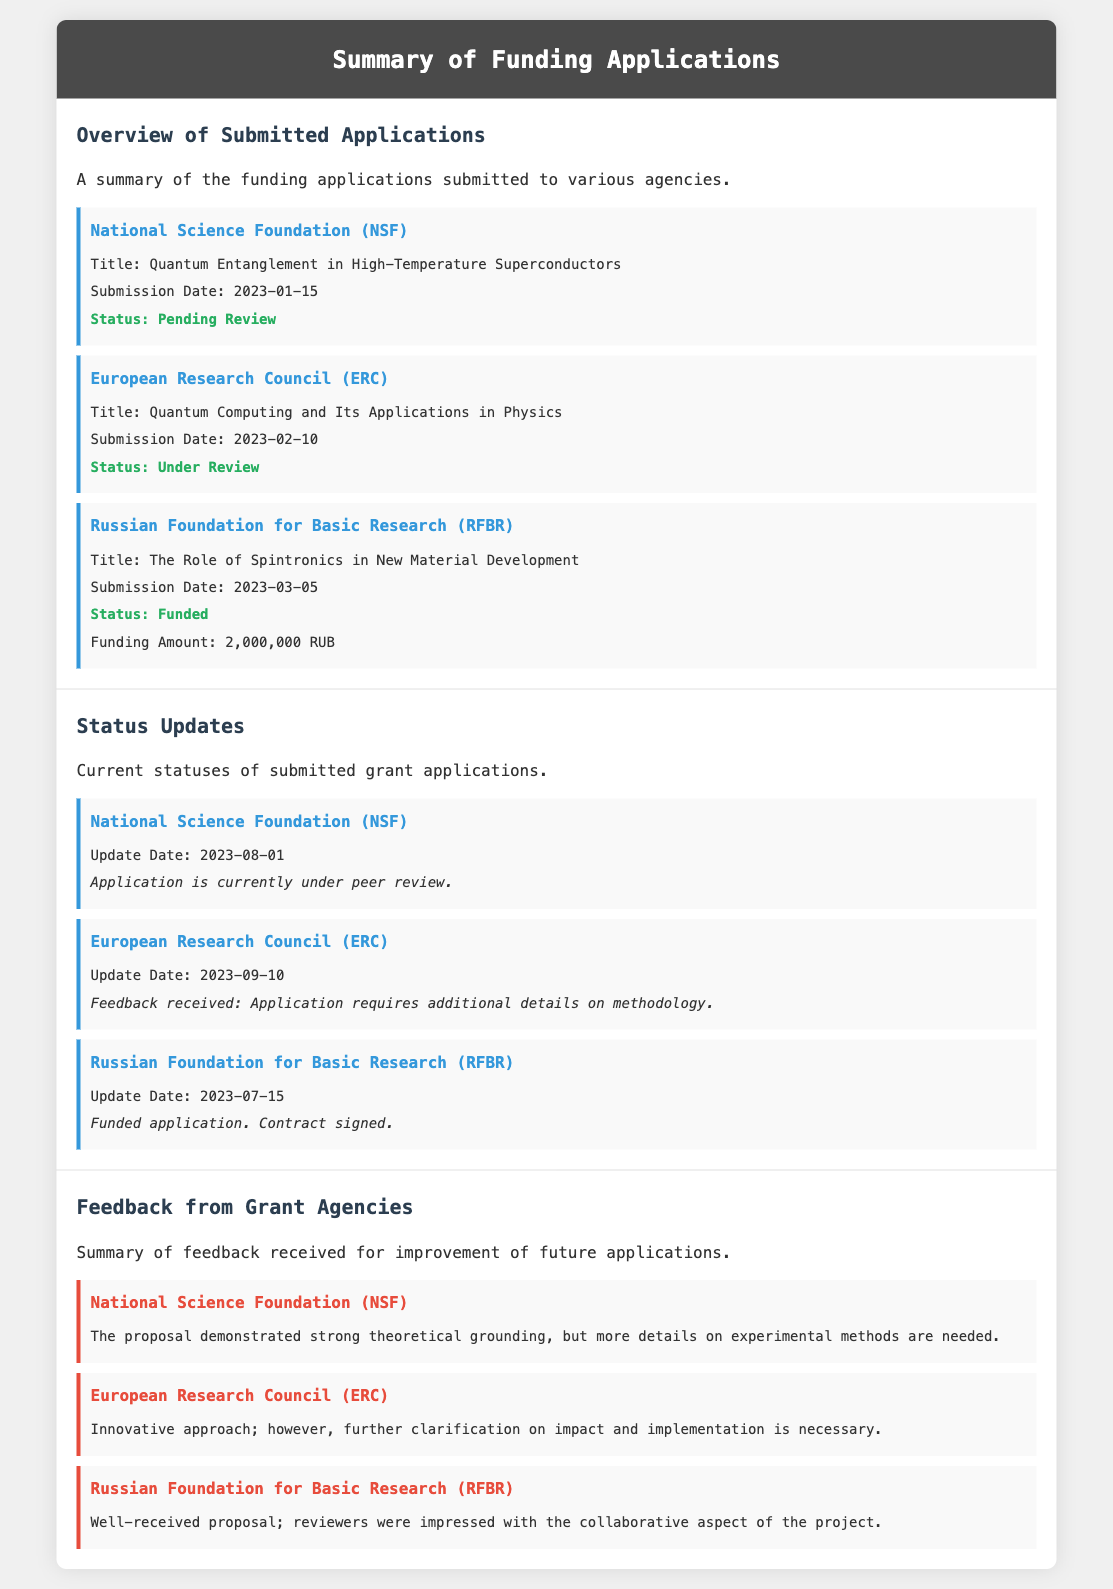What is the title of the NSF application? The title of the NSF application is stated as "Quantum Entanglement in High-Temperature Superconductors."
Answer: Quantum Entanglement in High-Temperature Superconductors What is the funding amount awarded by RFBR? The funding amount awarded by RFBR is explicitly stated in the document as 2,000,000 RUB.
Answer: 2,000,000 RUB When was the ERC application submitted? The submission date for the ERC application is provided in the document as 2023-02-10.
Answer: 2023-02-10 What feedback was received from ERC? The feedback states that the application requires additional details on methodology, which is specifically noted in the document.
Answer: Application requires additional details on methodology What is the status of the RFBR application? The status of the RFBR application is mentioned as "Funded."
Answer: Funded What date is the latest update for the NSF application? The latest update date for the NSF application is given as 2023-08-01 in the document.
Answer: 2023-08-01 Which grant agency's proposal was well-received due to its collaborative aspect? The document specifies that the RFBR proposal was well-received for its collaborative aspect.
Answer: Russian Foundation for Basic Research What was the status of the ERC application as of the last update? The last update for the ERC application indicates that it was still "Under Review."
Answer: Under Review How many applications have been submitted in total? There are three applications mentioned in the document: NSF, ERC, and RFBR.
Answer: Three 